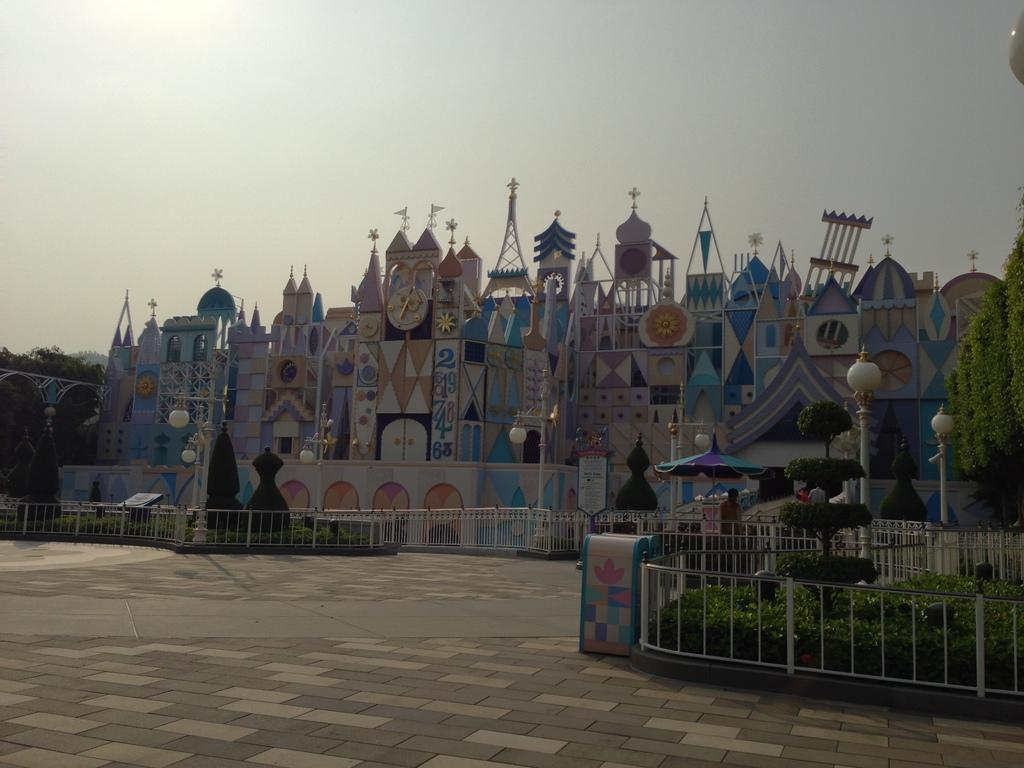What is the main subject of the image? The image contains a picture of Hong Kong Disneyland. What objects are in front of the picture? There are poles, lamps, trees, plants, and a railing in front of the picture. What can be seen in the background of the image? The sky is visible in the background of the image. What type of toothbrush is hanging from the branch in the image? There is no toothbrush or branch present in the image. What kind of growth can be seen on the railing in the image? There is no growth visible on the railing in the image. 